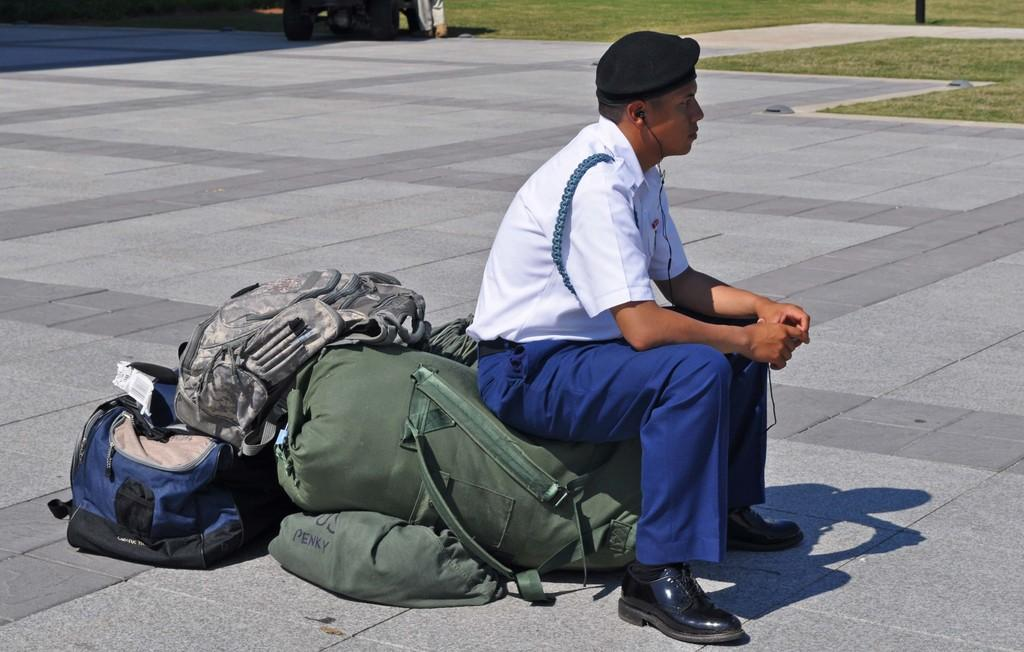What is the person in the image doing? The person is sitting on a bag in the image. What type of vegetation is visible on the right side of the image? Grass is present on the right side of the image. What type of building can be seen in the background of the image? There is no building visible in the background of the image. What type of fruit is the person eating for breakfast in the image? There is no fruit or breakfast depicted in the image. 